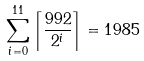Convert formula to latex. <formula><loc_0><loc_0><loc_500><loc_500>\sum _ { i = 0 } ^ { 1 1 } \left \lceil \frac { 9 9 2 } { 2 ^ { i } } \right \rceil = 1 9 8 5</formula> 